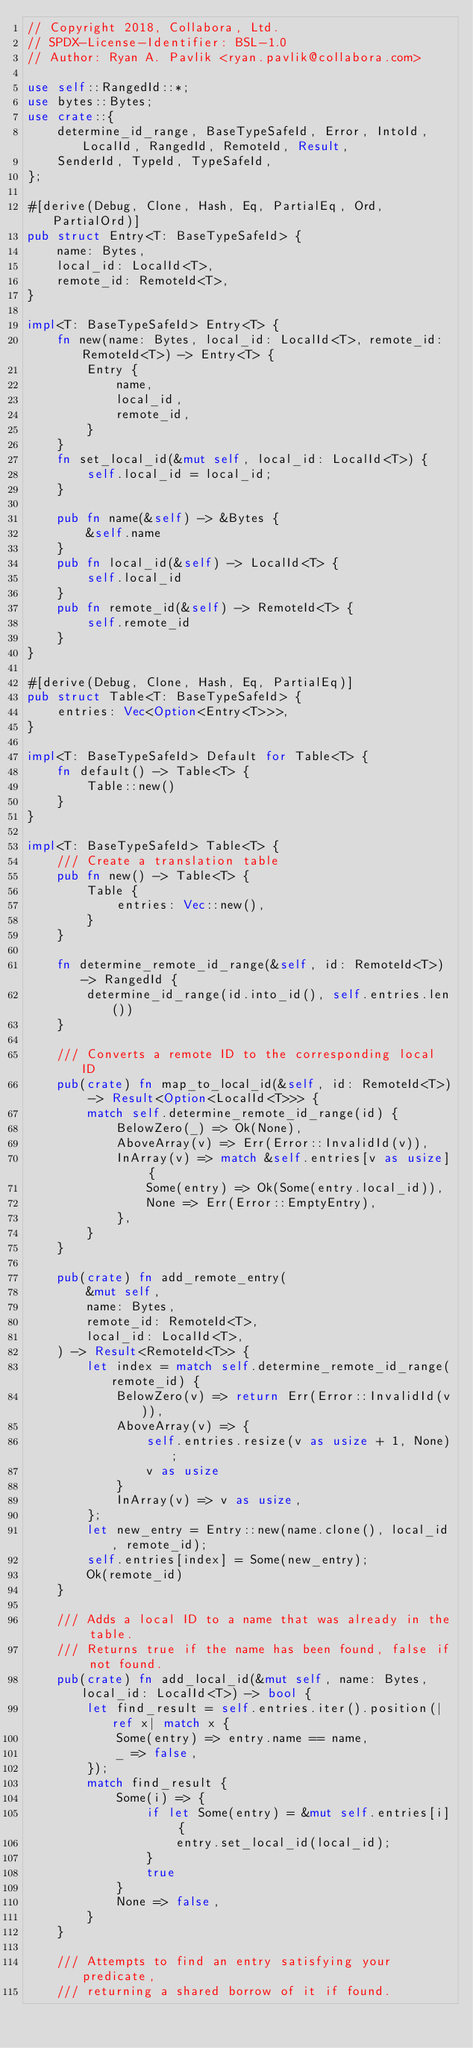<code> <loc_0><loc_0><loc_500><loc_500><_Rust_>// Copyright 2018, Collabora, Ltd.
// SPDX-License-Identifier: BSL-1.0
// Author: Ryan A. Pavlik <ryan.pavlik@collabora.com>

use self::RangedId::*;
use bytes::Bytes;
use crate::{
    determine_id_range, BaseTypeSafeId, Error, IntoId, LocalId, RangedId, RemoteId, Result,
    SenderId, TypeId, TypeSafeId,
};

#[derive(Debug, Clone, Hash, Eq, PartialEq, Ord, PartialOrd)]
pub struct Entry<T: BaseTypeSafeId> {
    name: Bytes,
    local_id: LocalId<T>,
    remote_id: RemoteId<T>,
}

impl<T: BaseTypeSafeId> Entry<T> {
    fn new(name: Bytes, local_id: LocalId<T>, remote_id: RemoteId<T>) -> Entry<T> {
        Entry {
            name,
            local_id,
            remote_id,
        }
    }
    fn set_local_id(&mut self, local_id: LocalId<T>) {
        self.local_id = local_id;
    }

    pub fn name(&self) -> &Bytes {
        &self.name
    }
    pub fn local_id(&self) -> LocalId<T> {
        self.local_id
    }
    pub fn remote_id(&self) -> RemoteId<T> {
        self.remote_id
    }
}

#[derive(Debug, Clone, Hash, Eq, PartialEq)]
pub struct Table<T: BaseTypeSafeId> {
    entries: Vec<Option<Entry<T>>>,
}

impl<T: BaseTypeSafeId> Default for Table<T> {
    fn default() -> Table<T> {
        Table::new()
    }
}

impl<T: BaseTypeSafeId> Table<T> {
    /// Create a translation table
    pub fn new() -> Table<T> {
        Table {
            entries: Vec::new(),
        }
    }

    fn determine_remote_id_range(&self, id: RemoteId<T>) -> RangedId {
        determine_id_range(id.into_id(), self.entries.len())
    }

    /// Converts a remote ID to the corresponding local ID
    pub(crate) fn map_to_local_id(&self, id: RemoteId<T>) -> Result<Option<LocalId<T>>> {
        match self.determine_remote_id_range(id) {
            BelowZero(_) => Ok(None),
            AboveArray(v) => Err(Error::InvalidId(v)),
            InArray(v) => match &self.entries[v as usize] {
                Some(entry) => Ok(Some(entry.local_id)),
                None => Err(Error::EmptyEntry),
            },
        }
    }

    pub(crate) fn add_remote_entry(
        &mut self,
        name: Bytes,
        remote_id: RemoteId<T>,
        local_id: LocalId<T>,
    ) -> Result<RemoteId<T>> {
        let index = match self.determine_remote_id_range(remote_id) {
            BelowZero(v) => return Err(Error::InvalidId(v)),
            AboveArray(v) => {
                self.entries.resize(v as usize + 1, None);
                v as usize
            }
            InArray(v) => v as usize,
        };
        let new_entry = Entry::new(name.clone(), local_id, remote_id);
        self.entries[index] = Some(new_entry);
        Ok(remote_id)
    }

    /// Adds a local ID to a name that was already in the table.
    /// Returns true if the name has been found, false if not found.
    pub(crate) fn add_local_id(&mut self, name: Bytes, local_id: LocalId<T>) -> bool {
        let find_result = self.entries.iter().position(|ref x| match x {
            Some(entry) => entry.name == name,
            _ => false,
        });
        match find_result {
            Some(i) => {
                if let Some(entry) = &mut self.entries[i] {
                    entry.set_local_id(local_id);
                }
                true
            }
            None => false,
        }
    }

    /// Attempts to find an entry satisfying your predicate,
    /// returning a shared borrow of it if found.</code> 